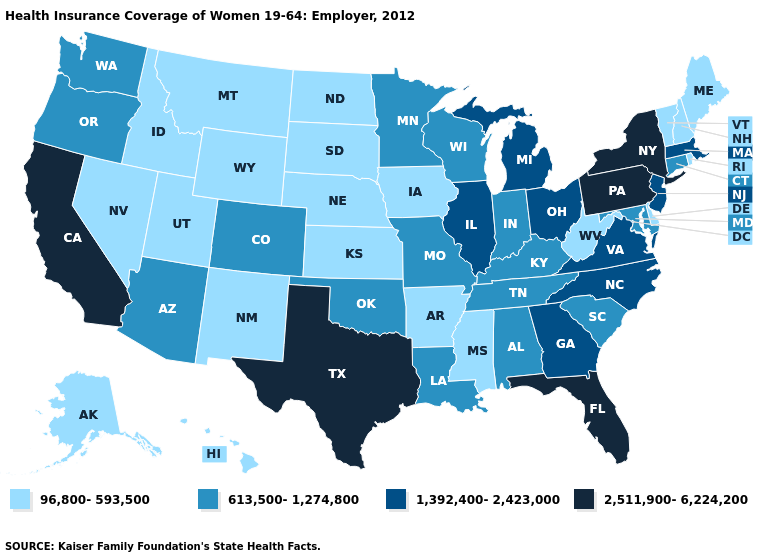Name the states that have a value in the range 613,500-1,274,800?
Quick response, please. Alabama, Arizona, Colorado, Connecticut, Indiana, Kentucky, Louisiana, Maryland, Minnesota, Missouri, Oklahoma, Oregon, South Carolina, Tennessee, Washington, Wisconsin. Does Connecticut have the lowest value in the Northeast?
Answer briefly. No. Name the states that have a value in the range 613,500-1,274,800?
Concise answer only. Alabama, Arizona, Colorado, Connecticut, Indiana, Kentucky, Louisiana, Maryland, Minnesota, Missouri, Oklahoma, Oregon, South Carolina, Tennessee, Washington, Wisconsin. Name the states that have a value in the range 1,392,400-2,423,000?
Keep it brief. Georgia, Illinois, Massachusetts, Michigan, New Jersey, North Carolina, Ohio, Virginia. What is the value of Colorado?
Be succinct. 613,500-1,274,800. What is the value of New York?
Answer briefly. 2,511,900-6,224,200. Does Texas have the highest value in the USA?
Keep it brief. Yes. What is the lowest value in the West?
Write a very short answer. 96,800-593,500. What is the value of South Dakota?
Answer briefly. 96,800-593,500. Does Louisiana have a higher value than New Mexico?
Concise answer only. Yes. Is the legend a continuous bar?
Write a very short answer. No. What is the value of South Carolina?
Be succinct. 613,500-1,274,800. Does South Dakota have the highest value in the MidWest?
Give a very brief answer. No. What is the value of South Dakota?
Keep it brief. 96,800-593,500. What is the value of Maine?
Answer briefly. 96,800-593,500. 